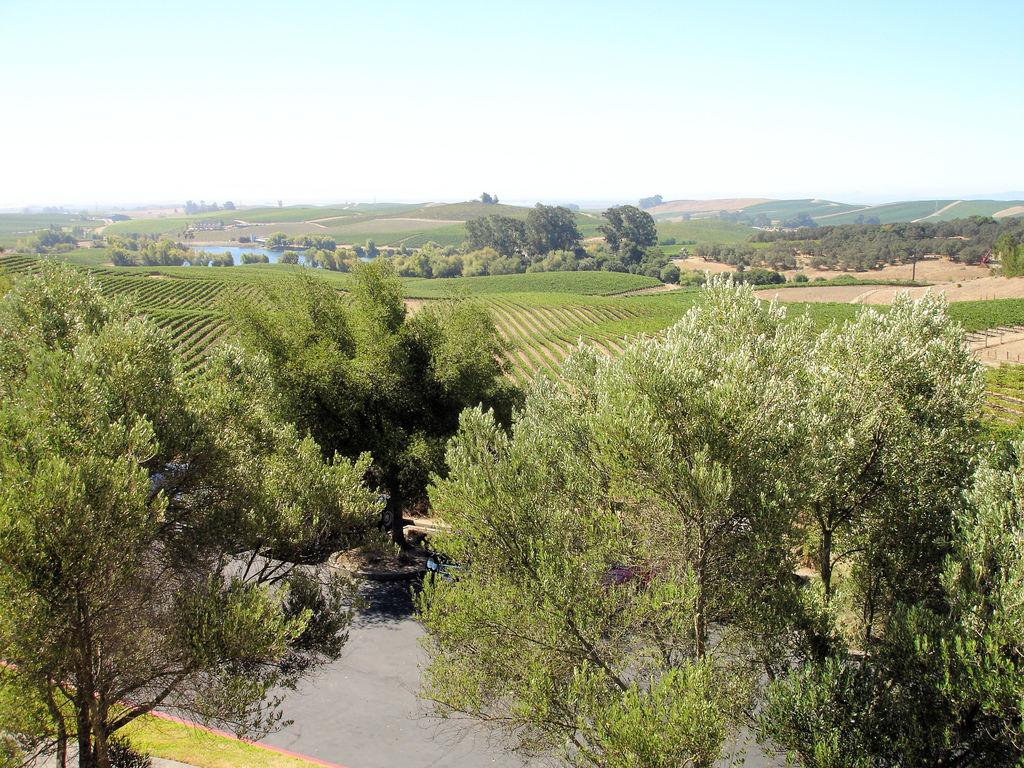What type of vegetation is present in the image? There are trees in the image. What else can be seen in the image besides trees? There is water and grass visible in the image. What is visible at the top of the image? The sky is visible at the top of the image. Can you see any trails made by women playing with toys in the image? There are no trails, women, or toys present in the image. 